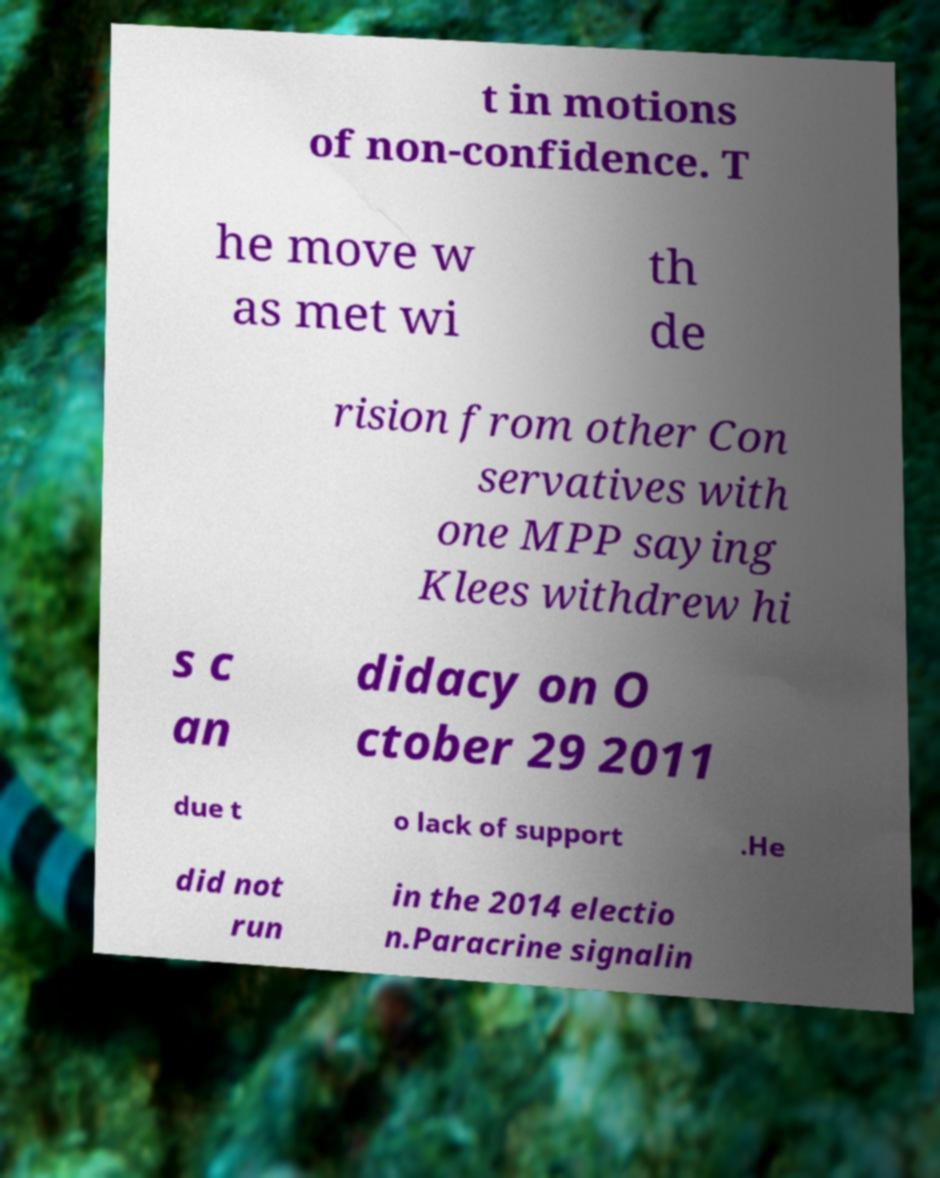For documentation purposes, I need the text within this image transcribed. Could you provide that? t in motions of non-confidence. T he move w as met wi th de rision from other Con servatives with one MPP saying Klees withdrew hi s c an didacy on O ctober 29 2011 due t o lack of support .He did not run in the 2014 electio n.Paracrine signalin 